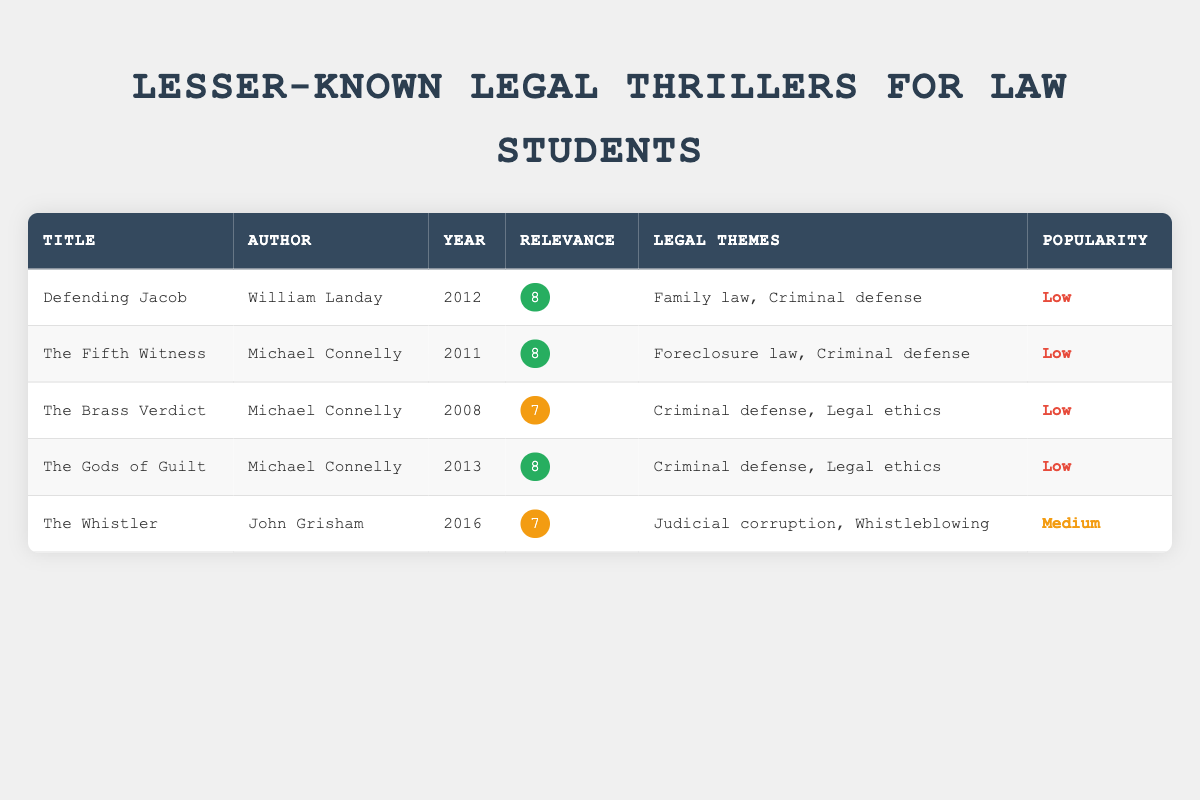What is the title of the book written by William Landay? The table lists the column for Title alongside the Author. By searching for William Landay in the Author column, we find the corresponding book title "Defending Jacob."
Answer: Defending Jacob Which book was published in the year 2011? By examining the publication year column, both "The Fifth Witness" and "The Litigators" are listed under 2011.
Answer: The Fifth Witness, The Litigators What is the relevance score of "The Gods of Guilt"? The relevance score column indicates that the score for "The Gods of Guilt" is 8.
Answer: 8 Is "A Time to Kill" more popular than "The Whistler"? The popularity for "A Time to Kill" is listed as High, while the popularity for "The Whistler" is Medium. Thus, "A Time to Kill" is indeed more popular.
Answer: Yes What is the average relevance score of the legal thrillers listed? The relevance scores are 8, 9, 7, 6, 8, 7, 8, 7, 8, and 7. Adding these scores gives 78. There are 10 titles, so the average relevance score is 78/10 = 7.8.
Answer: 7.8 Which legal theme is mentioned most frequently among the listed thrillers? Analyzing the legal themes across the entries, "Criminal defense" appears in 5 titles: "A Time to Kill," "The Lincoln Lawyer," "Defending Jacob," "The Fifth Witness," and "The Gods of Guilt." Thus, it is the most common theme.
Answer: Criminal defense How many books that have a relevance score of 7 or higher were published after 2005? The relevant entries are "The Fifth Witness" (2011), "The Gods of Guilt" (2013), and "The Whistler" (2016). There are 3 books with a score of 7 or higher published after 2005.
Answer: 3 Does any book by Michael Connelly have a popularity rating of Low? "The Brass Verdict," "The Fifth Witness," and "The Gods of Guilt," all authored by Michael Connelly, are listed with a Low popularity rating. So, the answer is yes.
Answer: Yes 